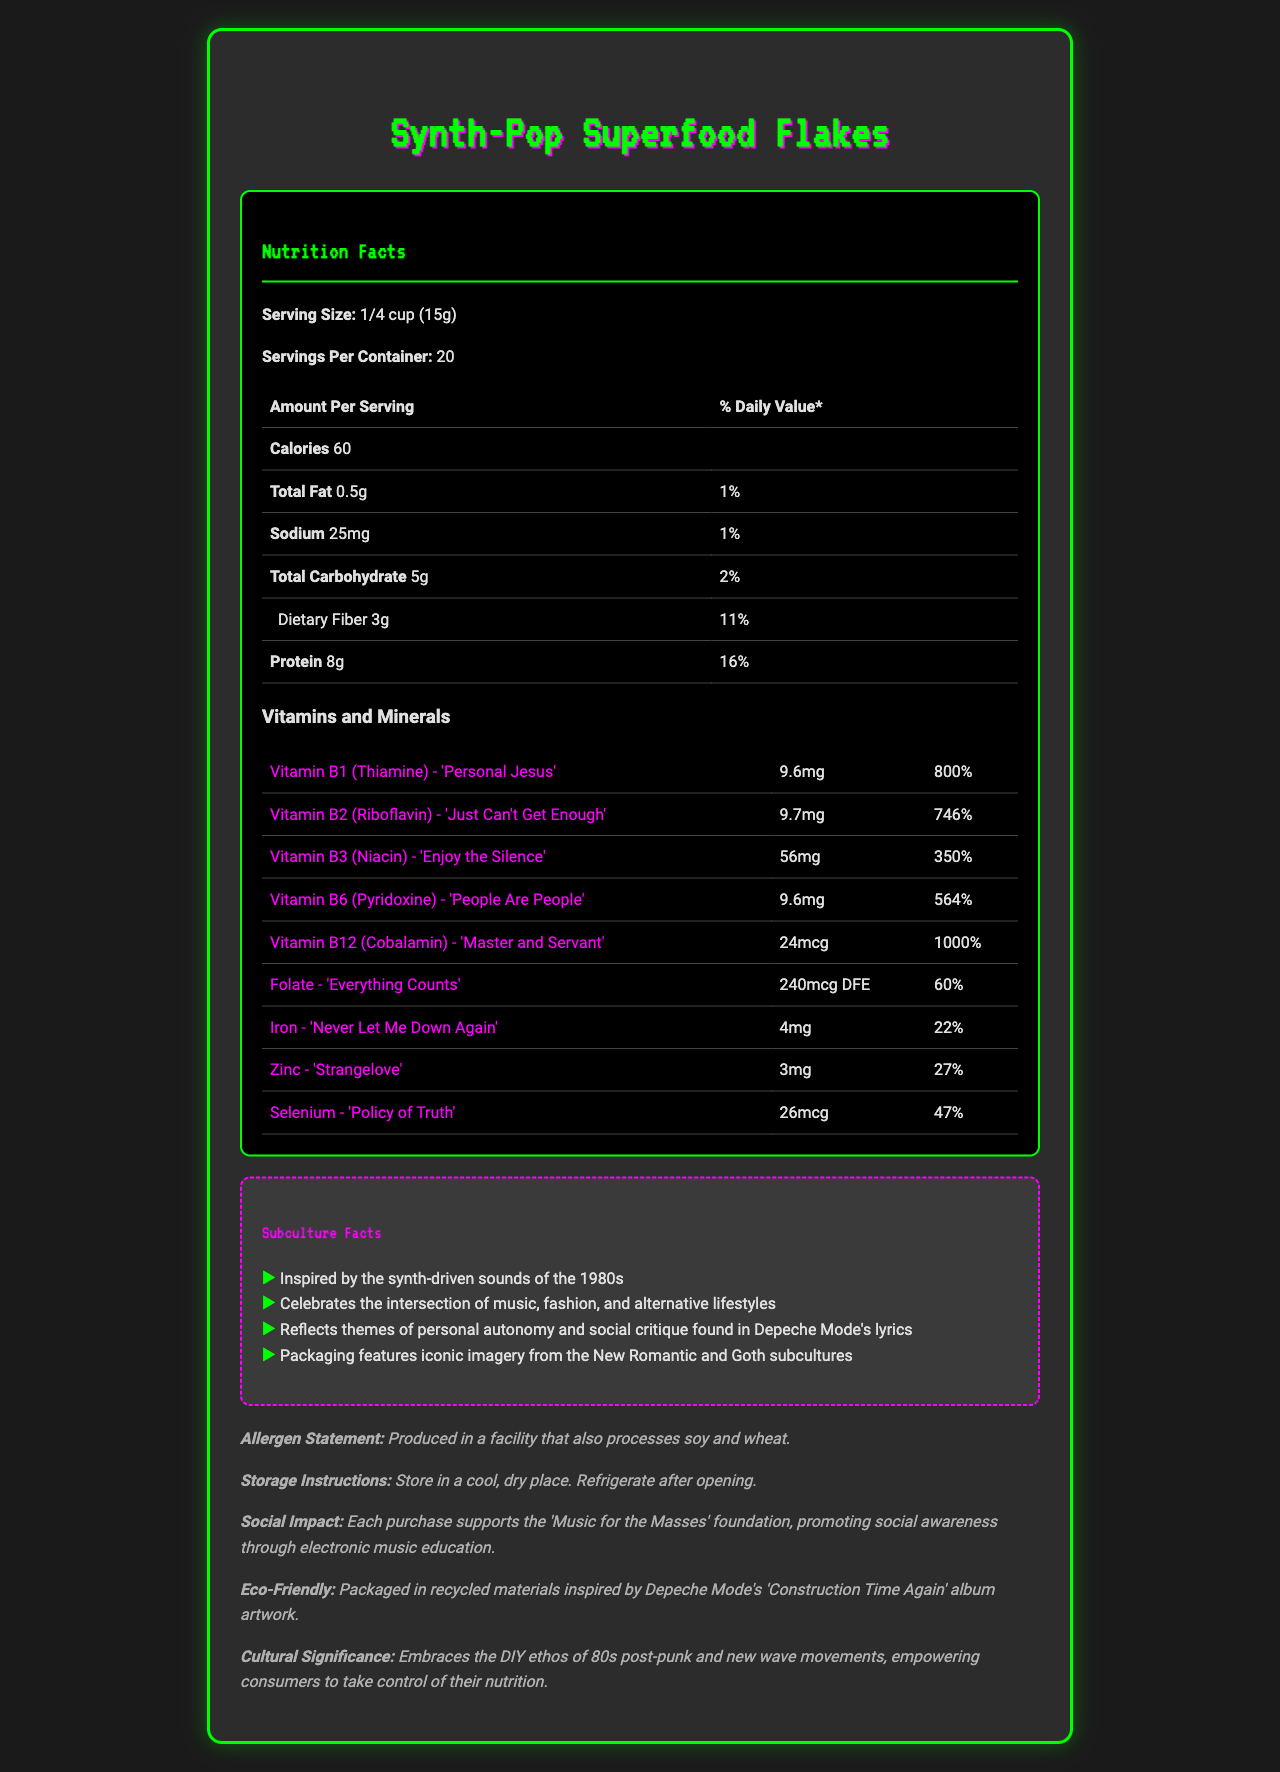what is the serving size? The serving size is explicitly listed as "1/4 cup (15g)" in the document.
Answer: 1/4 cup (15g) how many calories are in one serving? The document specifies that there are 60 calories per serving.
Answer: 60 what percentage of the daily value of protein does one serving provide? According to the document, each serving provides 8g of protein, which is 16% of the daily value.
Answer: 16% how much dietary fiber is in one serving? The document lists the amount of dietary fiber per serving as 3g.
Answer: 3g which vitamin has the highest daily value percentage? The document states that Vitamin B12 (Cobalamin) provides 1000% of the daily value per serving, which is the highest among listed vitamins and minerals.
Answer: Vitamin B12 (Cobalamin) - 'Master and Servant' how many servings are there in the container? The document notes that there are 20 servings per container.
Answer: 20 what is the product name? The product name "Synth-Pop Superfood Flakes" is prominently displayed on the document.
Answer: Synth-Pop Superfood Flakes which vitamin is associated with the song 'Enjoy the Silence'? The document links Vitamin B3 (Niacin) with the song 'Enjoy the Silence'.
Answer: Vitamin B3 (Niacin) how much Vitamin B1 is in one serving? The document states that there are 9.6mg of Vitamin B1 (Thiamine) per serving.
Answer: 9.6mg what Depeche Mode song is linked to Iron? A. 'Personal Jesus' B. 'Master and Servant' C. 'Never Let Me Down Again' D. 'Strangelove' The document associates Iron with the song 'Never Let Me Down Again'.
Answer: C which vitamin has a daily value of 746%? i. Vitamin B1 (Thiamine) ii. Vitamin B2 (Riboflavin) iii. Vitamin B3 (Niacin) iv. Vitamin B6 (Pyridoxine) Vitamin B2 (Riboflavin) has a daily value of 746% as indicated in the document.
Answer: ii does the product contain any allergens? The allergen statement notes that it is produced in a facility that also processes soy and wheat.
Answer: Yes what is the cultural significance of this product? The document emphasizes that the product embraces the DIY ethos of 80s post-punk and new wave movements, empowering consumers to take control of their nutrition.
Answer: Embraces the DIY ethos of 80s post-punk and new wave movements, empowering consumers to take control of their nutrition what additional social impact does purchasing this product have? The document states that each purchase supports the 'Music for the Masses' foundation.
Answer: Supports the 'Music for the Masses' foundation, promoting social awareness through electronic music education which vitamin linked to 'Policy of Truth' supports what social critique? The document mentions links between vitamins and Depeche Mode songs but does not provide details on specific social critiques associated with 'Policy of Truth'.
Answer: Not enough information describe the main theme of the document The document provides an in-depth look into the product "Synth-Pop Superfood Flakes," highlighting its nutritional content and unique 80s subculture-themed vitamins and minerals. It also underscores the product's cultural significance, social impact, and eco-friendly packaging.
Answer: Synth-Pop Superfood Flakes is a product blending nutrition with 80s subculture, specifically Depeche Mode. It includes comprehensive details on serving size, calories, macronutrients, and an extensive vitamin and mineral breakdown alongside song references. Additional sections highlight cultural significance, social impact, and eco-friendly packaging. 